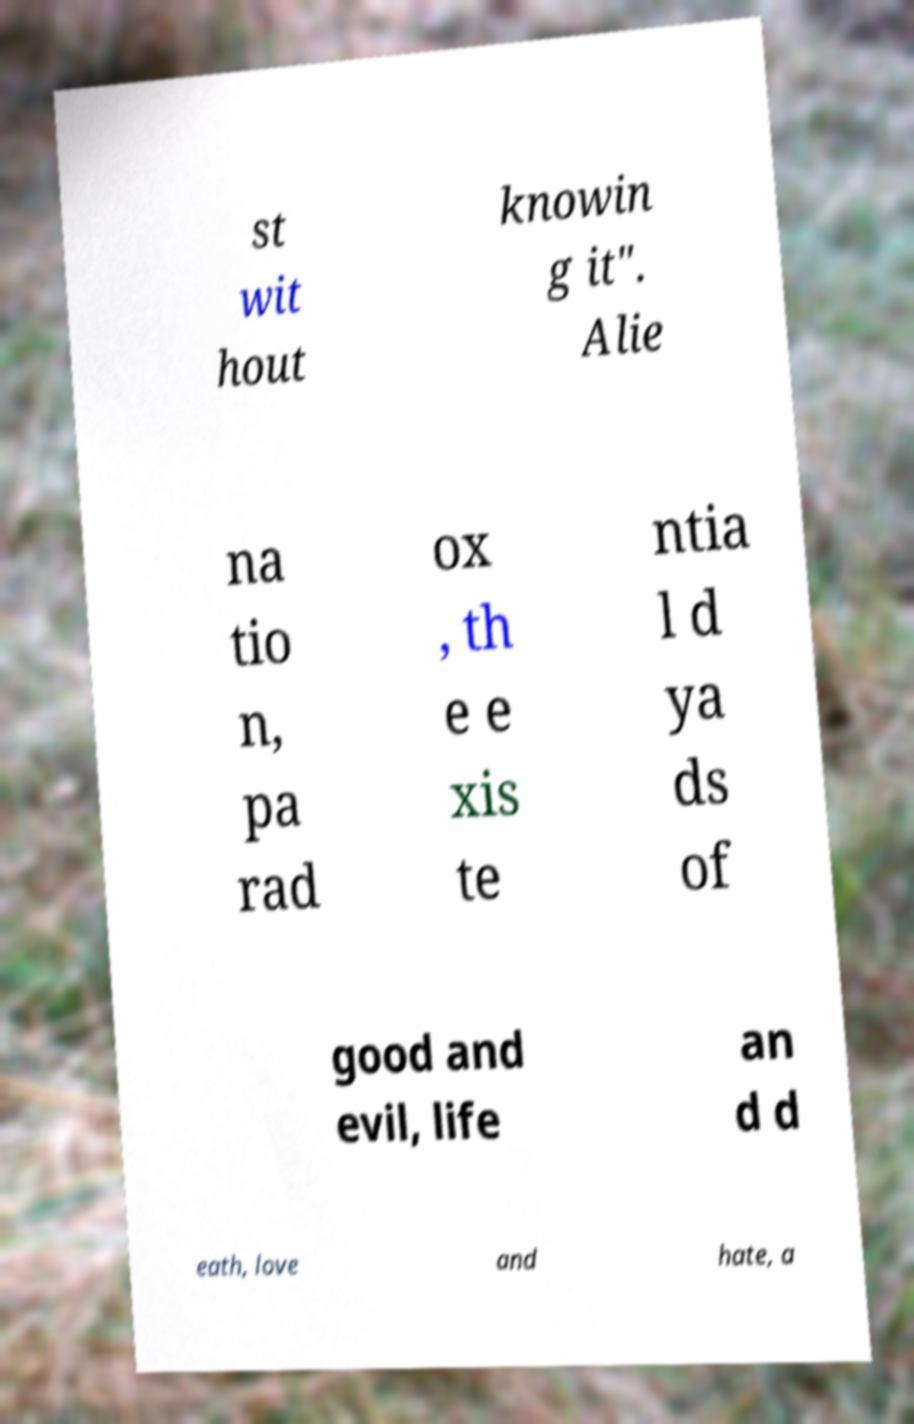Can you read and provide the text displayed in the image?This photo seems to have some interesting text. Can you extract and type it out for me? st wit hout knowin g it". Alie na tio n, pa rad ox , th e e xis te ntia l d ya ds of good and evil, life an d d eath, love and hate, a 